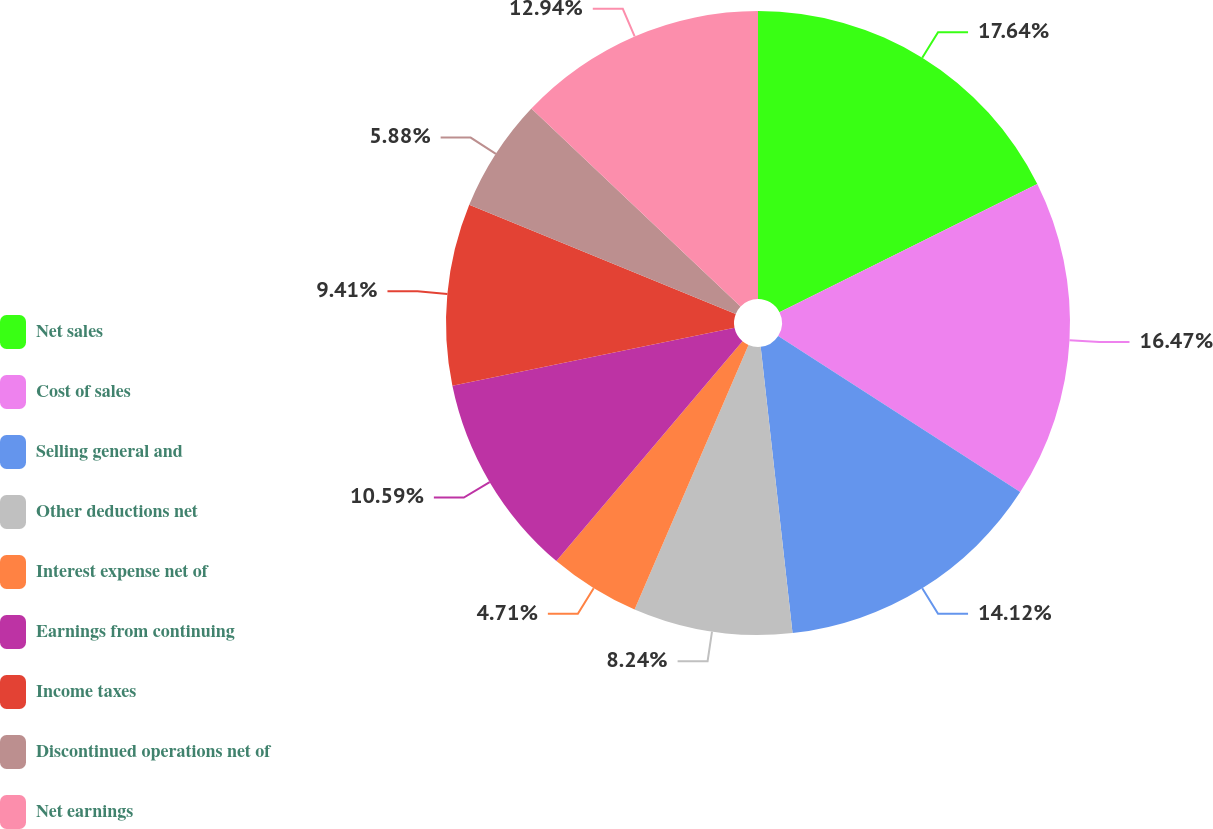Convert chart to OTSL. <chart><loc_0><loc_0><loc_500><loc_500><pie_chart><fcel>Net sales<fcel>Cost of sales<fcel>Selling general and<fcel>Other deductions net<fcel>Interest expense net of<fcel>Earnings from continuing<fcel>Income taxes<fcel>Discontinued operations net of<fcel>Net earnings<nl><fcel>17.65%<fcel>16.47%<fcel>14.12%<fcel>8.24%<fcel>4.71%<fcel>10.59%<fcel>9.41%<fcel>5.88%<fcel>12.94%<nl></chart> 